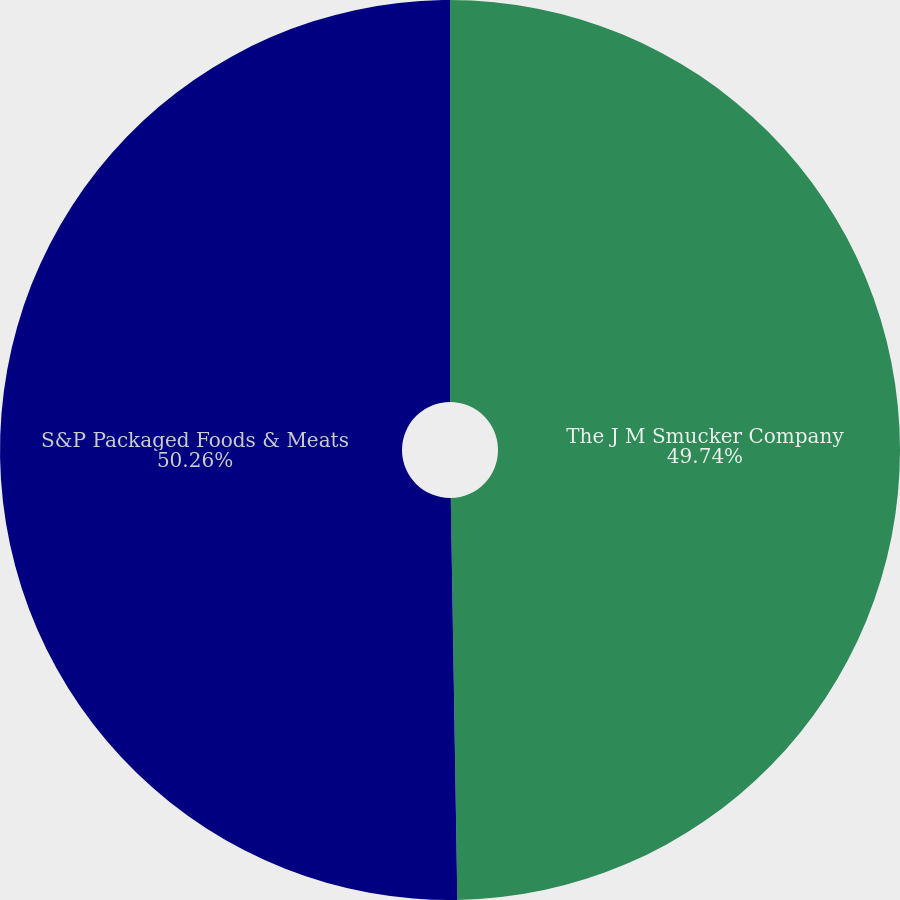<chart> <loc_0><loc_0><loc_500><loc_500><pie_chart><fcel>The J M Smucker Company<fcel>S&P Packaged Foods & Meats<nl><fcel>49.74%<fcel>50.26%<nl></chart> 